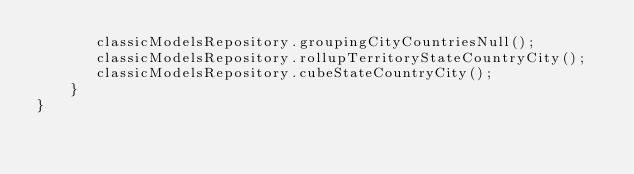<code> <loc_0><loc_0><loc_500><loc_500><_Java_>       classicModelsRepository.groupingCityCountriesNull();
       classicModelsRepository.rollupTerritoryStateCountryCity();
       classicModelsRepository.cubeStateCountryCity();
    }
}
</code> 